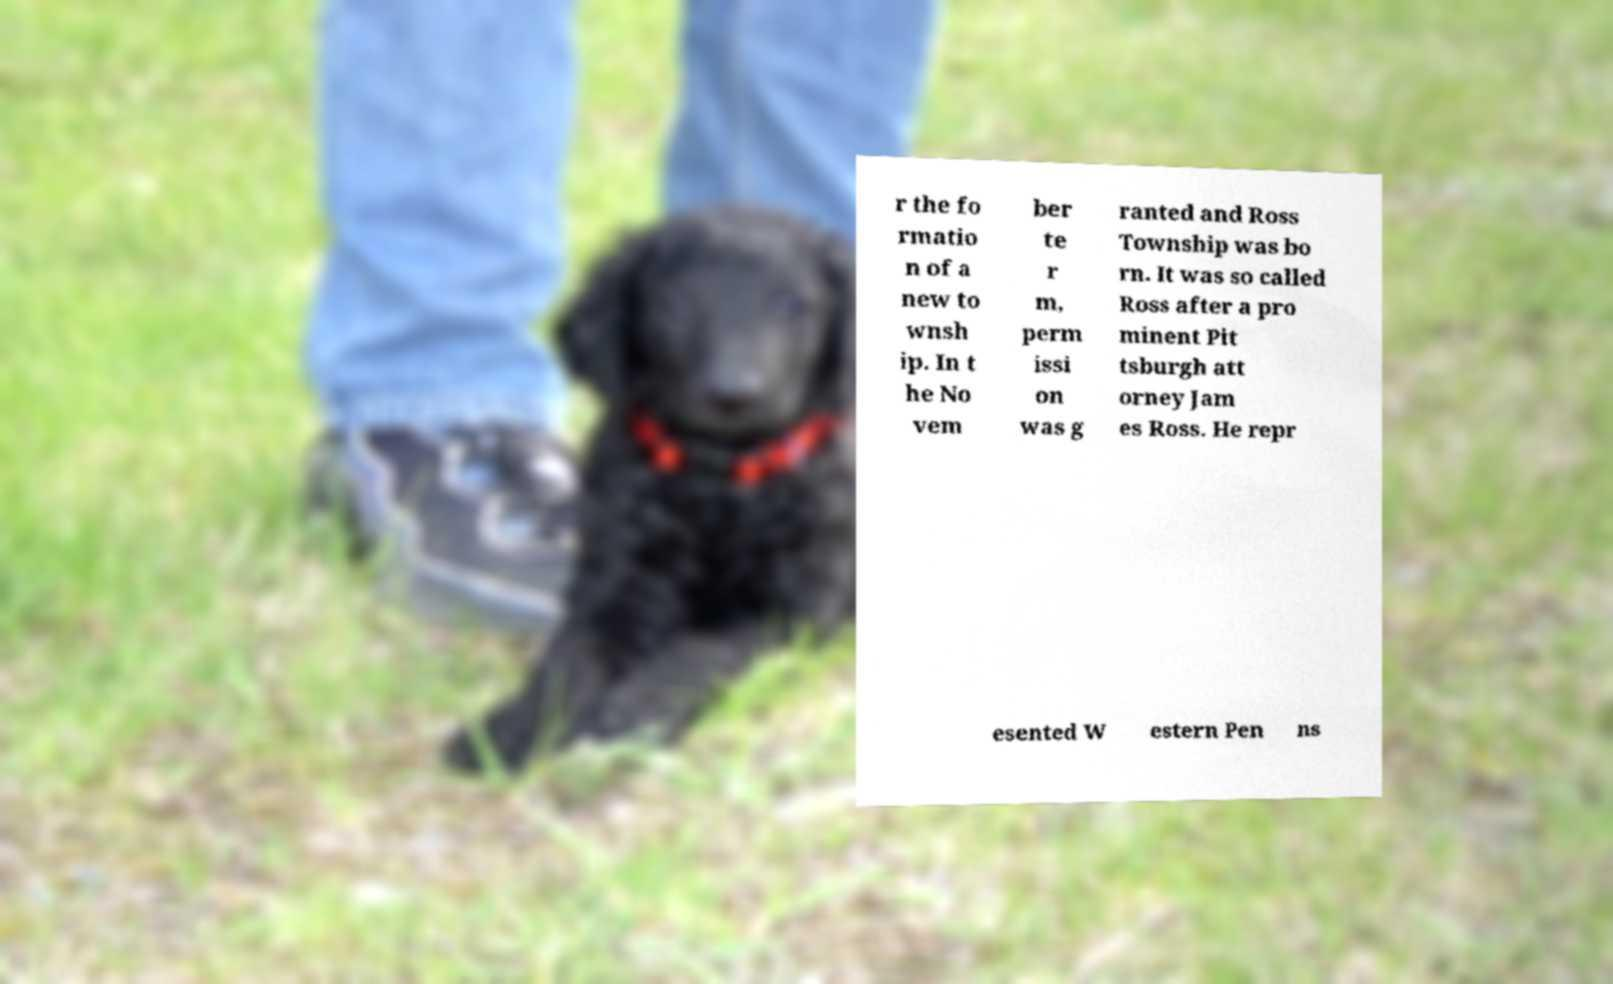I need the written content from this picture converted into text. Can you do that? r the fo rmatio n of a new to wnsh ip. In t he No vem ber te r m, perm issi on was g ranted and Ross Township was bo rn. It was so called Ross after a pro minent Pit tsburgh att orney Jam es Ross. He repr esented W estern Pen ns 